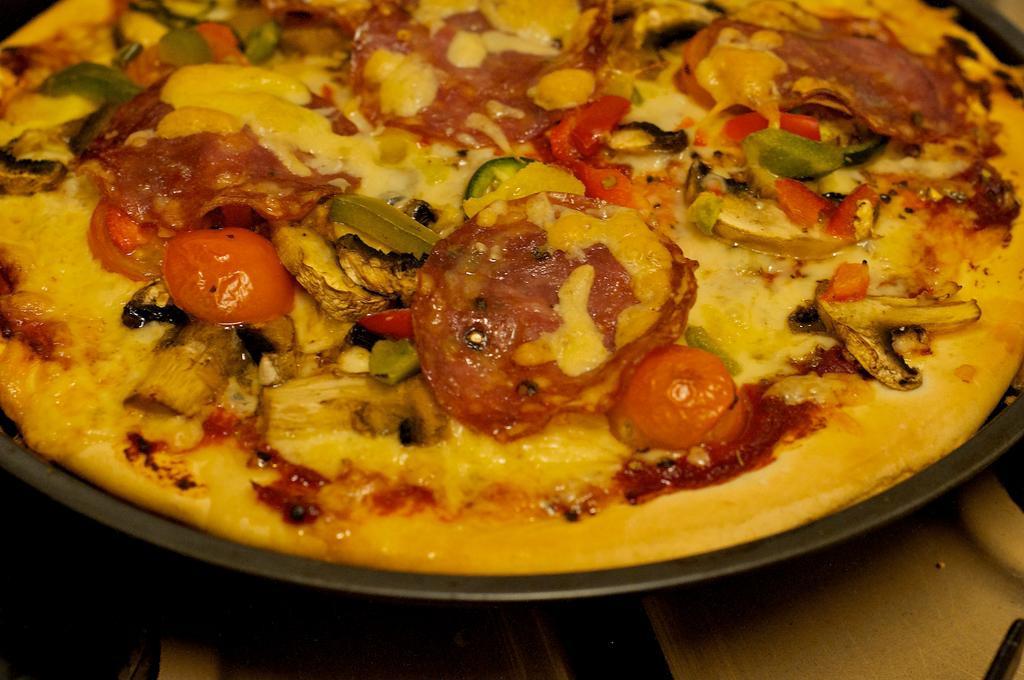How would you summarize this image in a sentence or two? In this picture we can see a pizza on a pan. This pan is visible on the platform. 